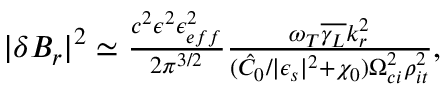Convert formula to latex. <formula><loc_0><loc_0><loc_500><loc_500>\begin{array} { r } { | \delta B _ { r } | ^ { 2 } \simeq \frac { c ^ { 2 } \epsilon ^ { 2 } \epsilon _ { e f f } ^ { 2 } } { 2 \pi ^ { 3 / 2 } } \frac { \omega _ { T } \overline { { \gamma _ { L } } } k _ { r } ^ { 2 } } { ( \hat { C } _ { 0 } / | \epsilon _ { s } | ^ { 2 } + \chi _ { 0 } ) \Omega _ { c i } ^ { 2 } \rho _ { i t } ^ { 2 } } , } \end{array}</formula> 